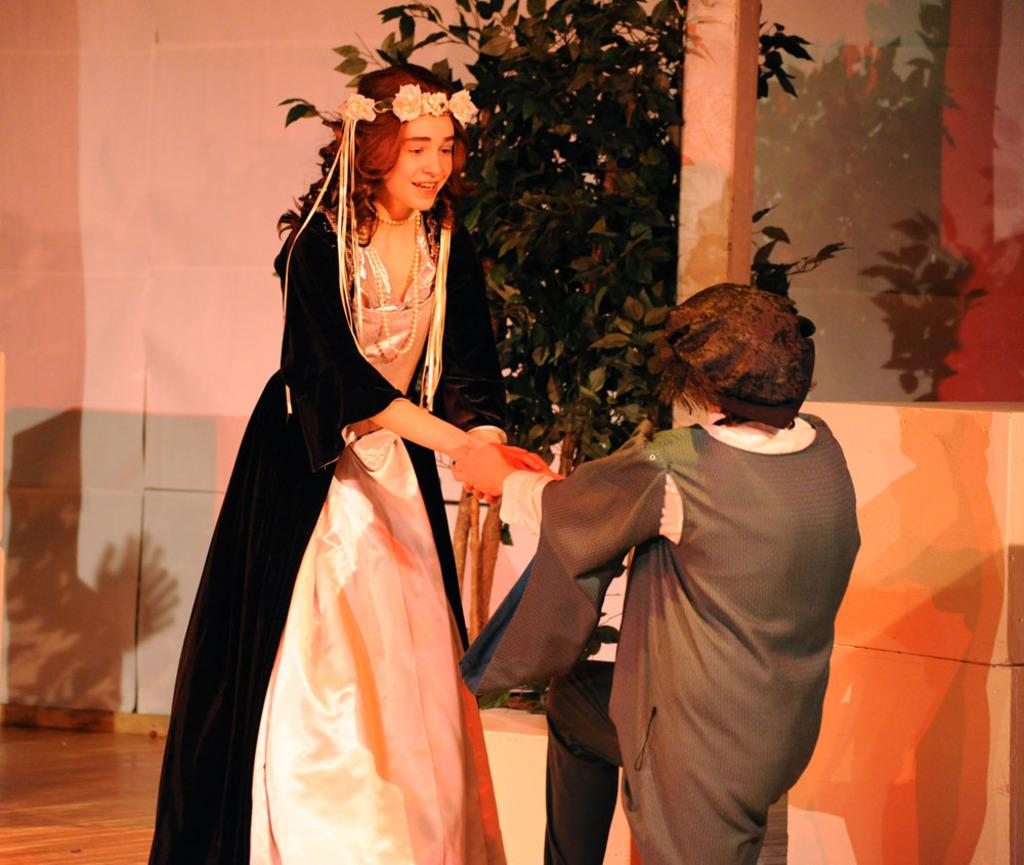How many people are present in the image? There are two persons standing in the image. Are the two persons interacting with each other? Yes, a person is holding another person's hand. What can be seen in the background of the image? There is a plant and a wall in the background of the image. What type of canvas is visible in the image? There is no canvas present in the image. What emotion does the cub display in the image? There is no cub present in the image. 